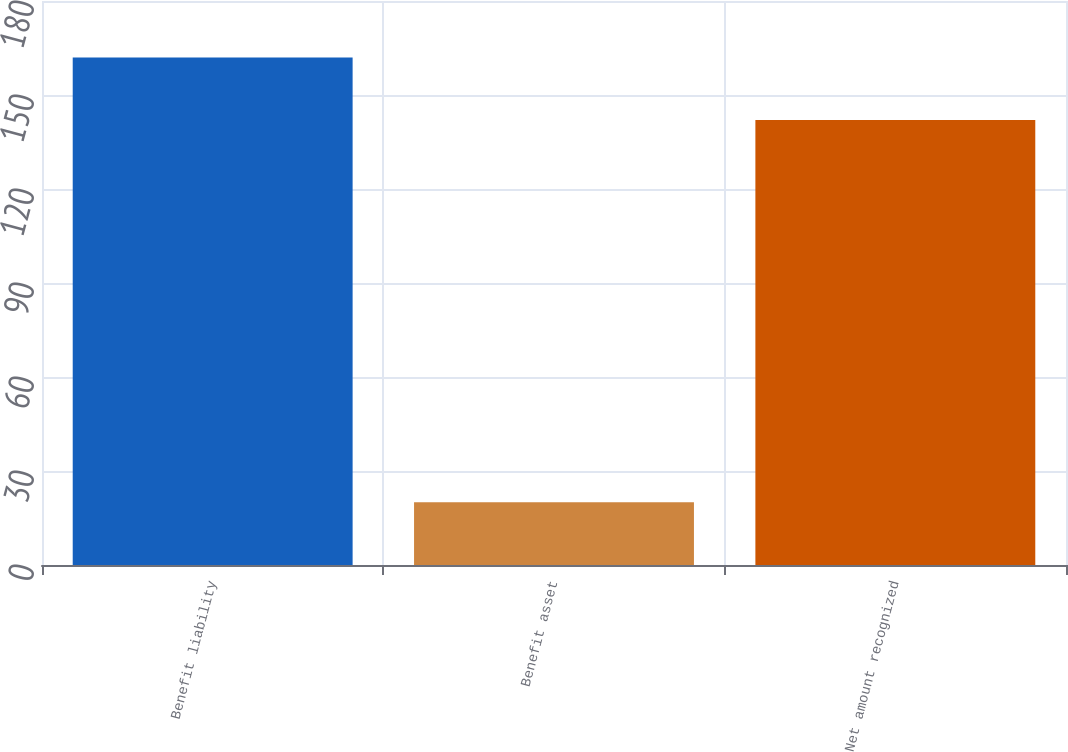<chart> <loc_0><loc_0><loc_500><loc_500><bar_chart><fcel>Benefit liability<fcel>Benefit asset<fcel>Net amount recognized<nl><fcel>162<fcel>20<fcel>142<nl></chart> 